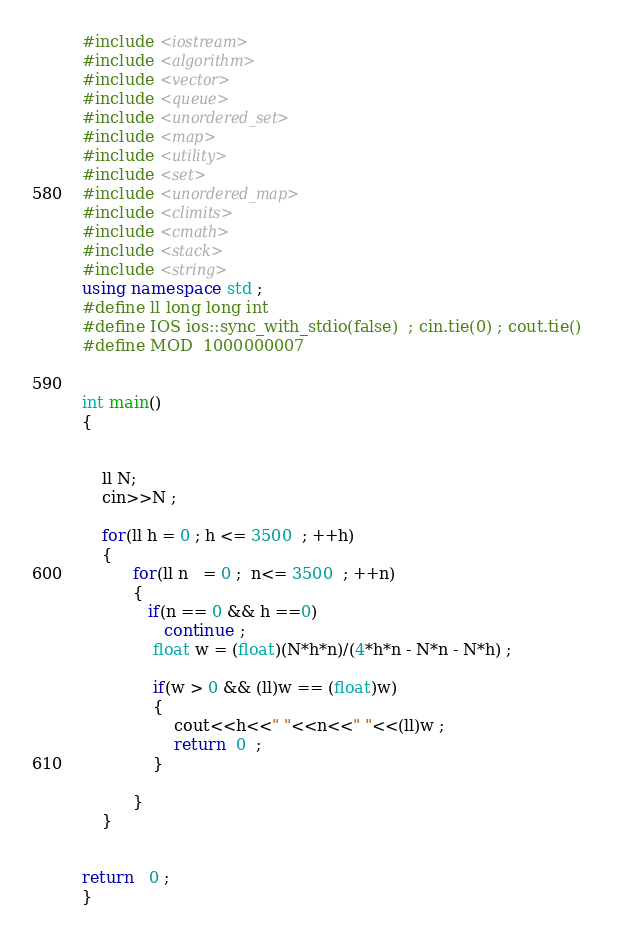<code> <loc_0><loc_0><loc_500><loc_500><_C++_>#include <iostream>
#include <algorithm>
#include <vector>
#include <queue>
#include <unordered_set>
#include <map>
#include <utility>
#include <set>
#include <unordered_map>
#include <climits>
#include <cmath>
#include <stack>
#include <string>
using namespace std ;
#define ll long long int 
#define IOS ios::sync_with_stdio(false)  ; cin.tie(0) ; cout.tie()  
#define MOD  1000000007  


int main()
{

	
	ll N;
	cin>>N ; 

	for(ll h = 0 ; h <= 3500  ; ++h)
	{
		  for(ll n   = 0 ;  n<= 3500  ; ++n)
		  {
		  	 if(n == 0 && h ==0)
		  	 	continue ; 
              float w = (float)(N*h*n)/(4*h*n - N*n - N*h) ; 
              
              if(w > 0 && (ll)w == (float)w)
              {
                  cout<<h<<" "<<n<<" "<<(ll)w ; 
                  return  0  ; 
              }

		  }
	} 

	
return   0 ;
}</code> 